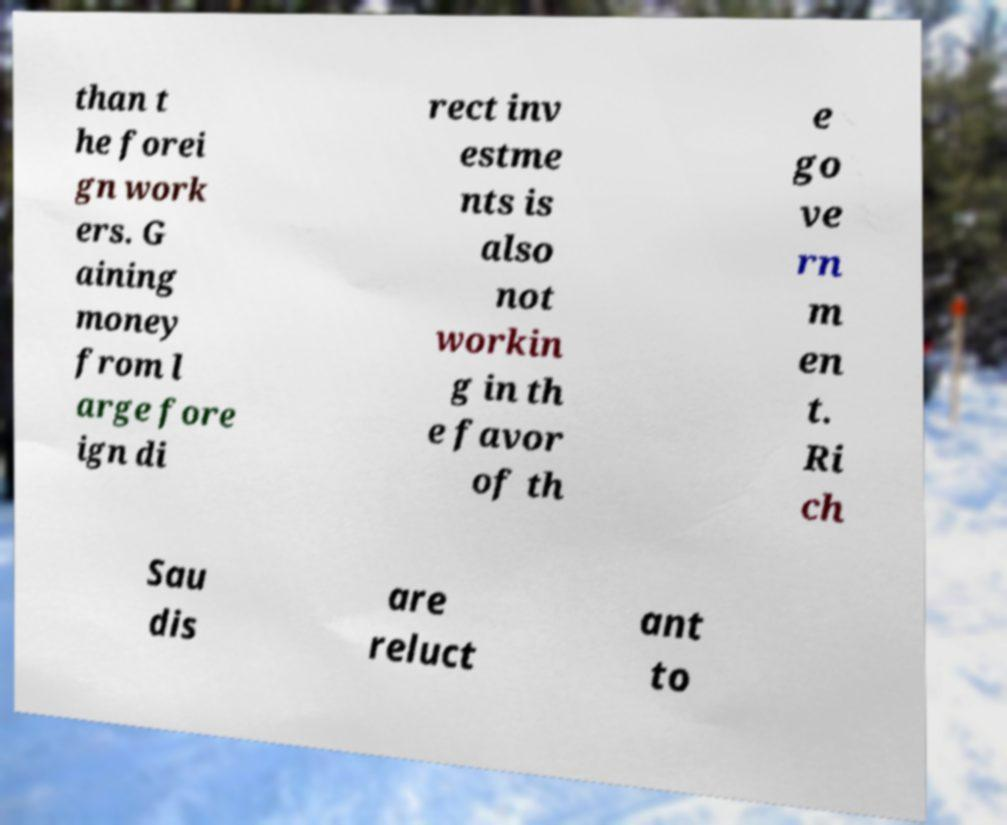Can you accurately transcribe the text from the provided image for me? than t he forei gn work ers. G aining money from l arge fore ign di rect inv estme nts is also not workin g in th e favor of th e go ve rn m en t. Ri ch Sau dis are reluct ant to 